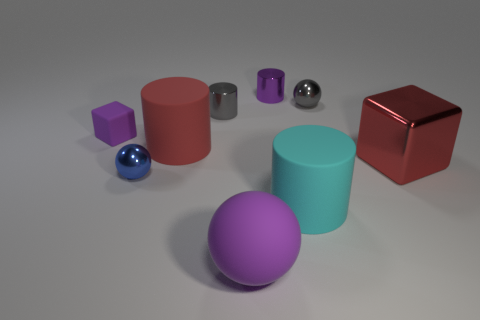There is a block right of the metal sphere that is in front of the small ball that is behind the large metal block; what is its size?
Make the answer very short. Large. What number of other objects are there of the same material as the small blue thing?
Provide a short and direct response. 4. What size is the purple rubber object that is in front of the big cyan matte cylinder?
Offer a terse response. Large. How many big things are on the right side of the big rubber ball and in front of the red cube?
Ensure brevity in your answer.  1. There is a small cylinder that is on the left side of the purple object that is behind the tiny rubber block; what is its material?
Give a very brief answer. Metal. What is the material of the purple thing that is the same shape as the blue metal object?
Your answer should be very brief. Rubber. Are there any gray metallic things?
Your response must be concise. Yes. The red object that is the same material as the tiny blue object is what shape?
Offer a terse response. Cube. There is a large cylinder that is behind the blue object; what is it made of?
Provide a short and direct response. Rubber. There is a big thing in front of the big cyan rubber object; is it the same color as the small rubber block?
Provide a succinct answer. Yes. 